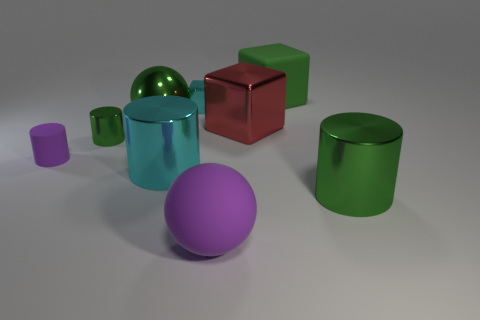The red object that is the same material as the big cyan thing is what shape?
Your response must be concise. Cube. The large ball in front of the cylinder to the right of the rubber object behind the red object is made of what material?
Give a very brief answer. Rubber. What number of objects are small metallic objects that are in front of the red thing or brown shiny things?
Keep it short and to the point. 1. How many other objects are there of the same shape as the red metallic thing?
Your answer should be compact. 2. Is the number of red metallic blocks in front of the matte block greater than the number of tiny yellow metallic balls?
Your response must be concise. Yes. The cyan thing that is the same shape as the red metal object is what size?
Provide a succinct answer. Small. There is a small rubber thing; what shape is it?
Your answer should be compact. Cylinder. The green metallic object that is the same size as the matte cylinder is what shape?
Ensure brevity in your answer.  Cylinder. Is there anything else that has the same color as the tiny metallic cylinder?
Your answer should be very brief. Yes. There is a purple cylinder that is the same material as the big purple ball; what is its size?
Ensure brevity in your answer.  Small. 